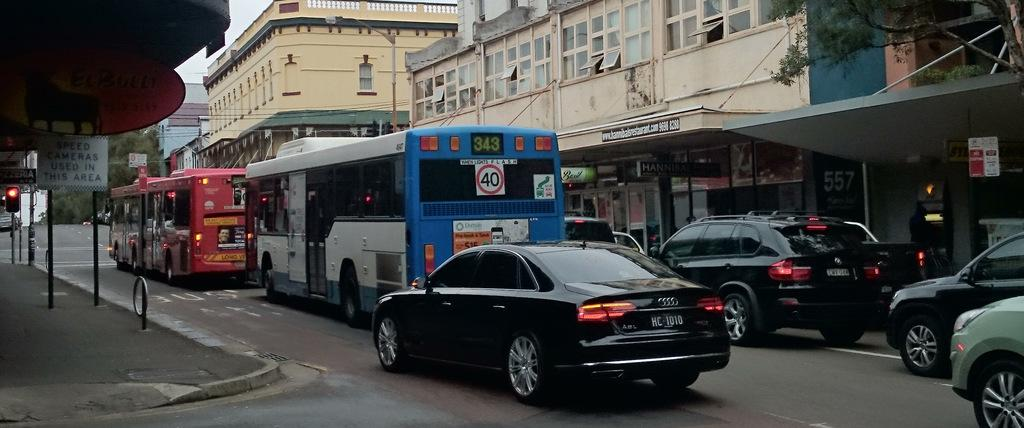What type of vehicle is in the image? There is a black car in the image. What is the car doing in the image? The car is moving on the road. Are there any other vehicles in the image? Yes, there are two buses in front of the car. What are the buses doing in the image? The buses are also moving. What can be seen on the right side of the image? There are buildings on the right side of the image. Can you tell me how many fans are visible in the image? There are no fans present in the image. What type of trail can be seen behind the car in the image? There is no trail visible behind the car in the image. 